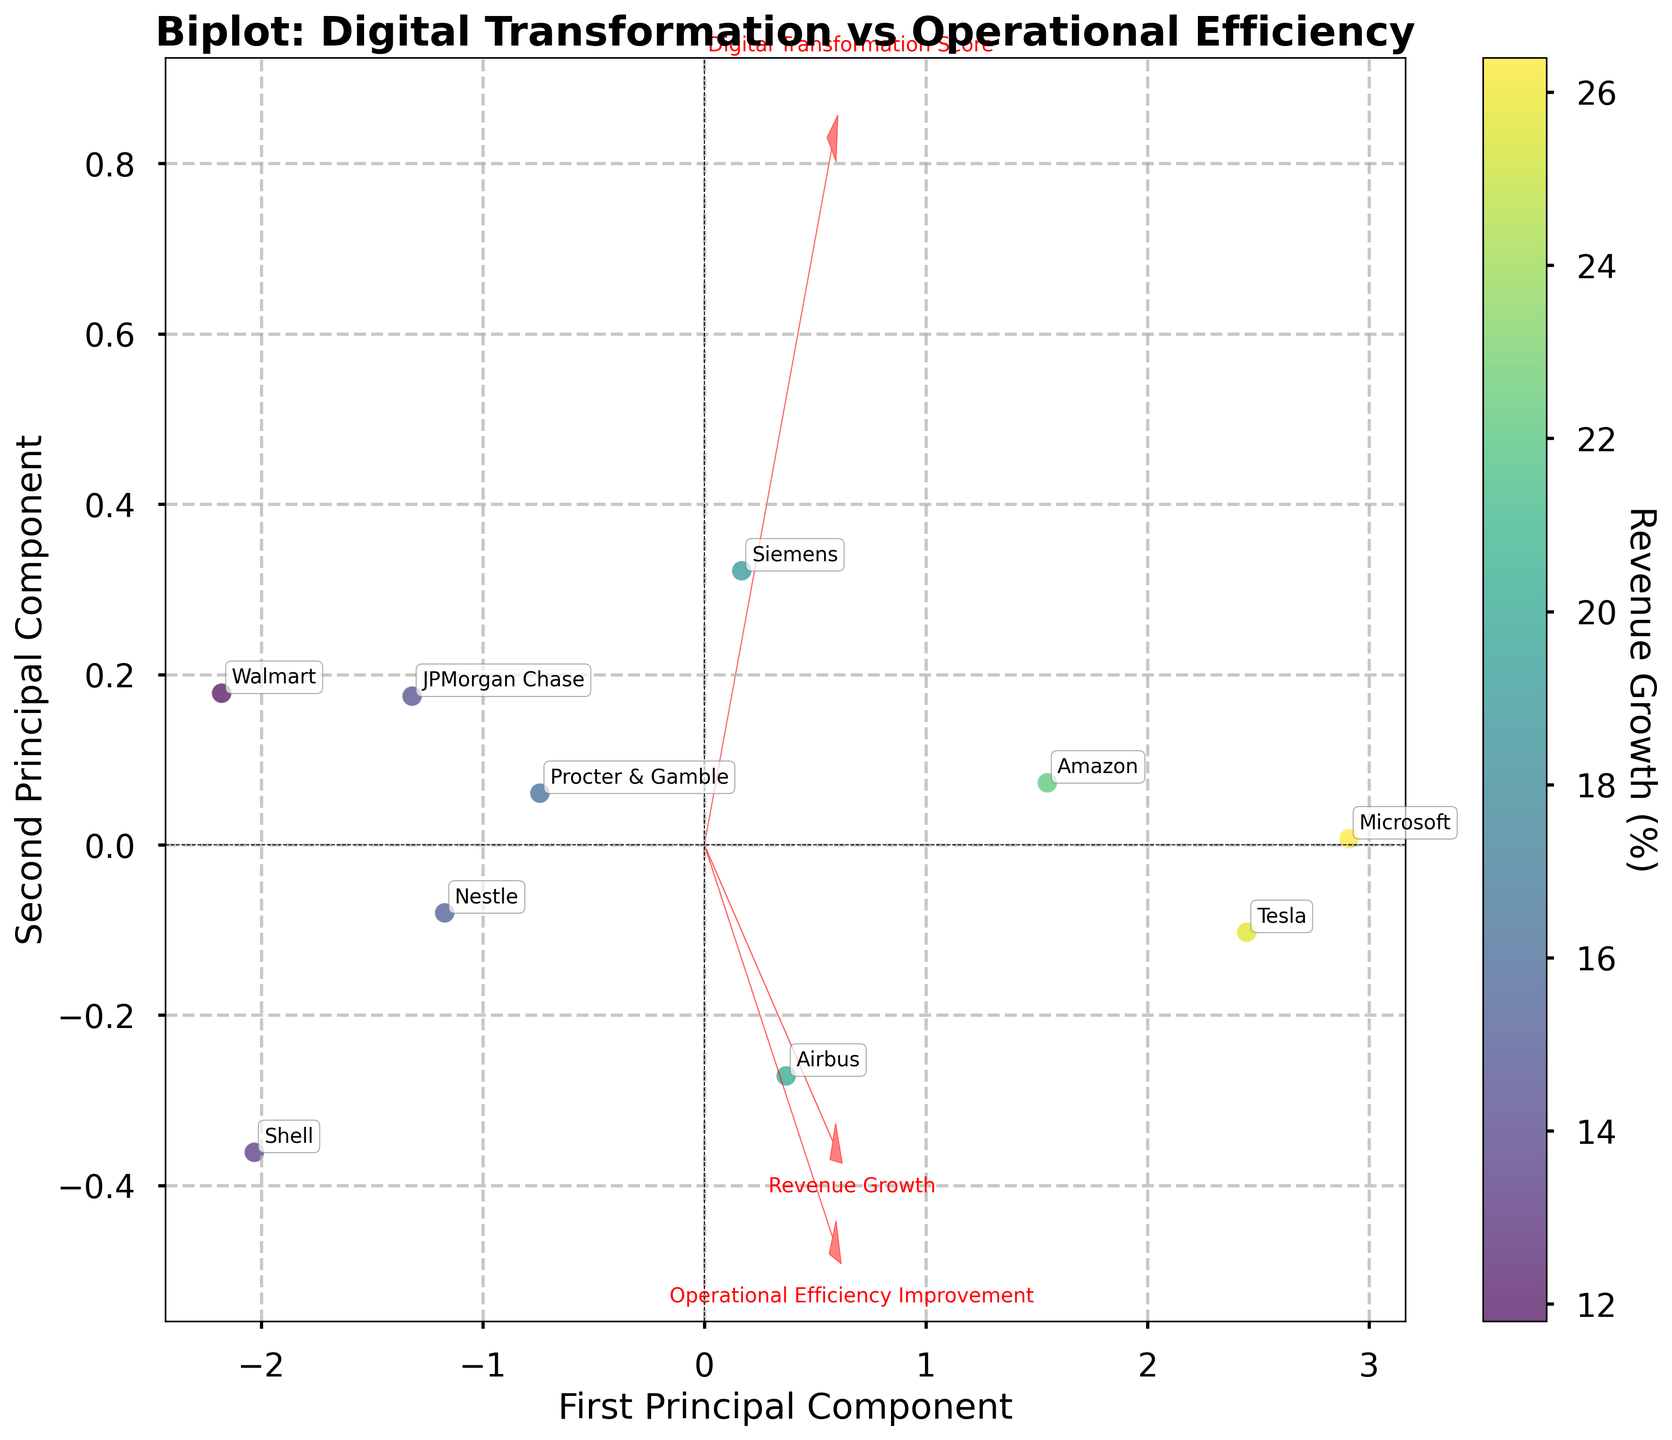What's the title of the plot? The title is usually located at the top of the plot. By reading it, we can understand the main focus of the visualization.
Answer: Biplot: Digital Transformation vs Operational Efficiency How many companies are represented in the plot? Each data point in the scatter plot corresponds to a company, and the annotations for each point show the company names. Count the number of points and annotations.
Answer: 10 Which company shows the highest operational efficiency improvement? The operational efficiency improvement can be inferred from the component vectors. The company represented by the point farthest along the Operational Efficiency Improvement axis indicates the highest improvement.
Answer: Microsoft Is there a positive or negative relationship between Digital Transformation Score and Operational Efficiency Improvement based on the plot? Observe the direction of the arrows representing the features. If the arrows for Digital Transformation Score and Operational Efficiency Improvement point in generally the same direction, it indicates a positive relationship.
Answer: Positive Which two companies appear closest to each other on the plot? Look at the scatter points and their annotations to identify the two companies whose points are nearest to each other on the plot.
Answer: Siemens and Procter & Gamble In which quadrant is Tesla located? Determine the coordinate of Tesla's scatter point in relation to the origin (0,0), then identify the quadrant it falls into.
Answer: First Quadrant Compare the Revenue Growth for Amazon and Walmart. Which one is higher? Analyze the color shade of the scatter points for Amazon and Walmart. The Revenue Growth is indicated by color intensity, where a lighter color represents higher revenue growth.
Answer: Amazon Which industry is most represented in the plot? Examine the annotations and check which industry appears most frequently among the company names.
Answer: No single industry is most represented What is the relationship between Revenue Growth and the first principal component? Observe the scatter plot color intensity along the first principal component axis. If the intensity increases or decreases uniformly, it indicates the relationship type.
Answer: Positive relationship Are companies with both high Digital Transformation Score and high Operational Efficiency Improvement concentrated in a specific part of the plot? Check the scatter plot area where the vectors of both Digital Transformation Score and Operational Efficiency Improvement point. If companies are clustered in that region, it indicates concentration.
Answer: Yes, in the first quadrant 